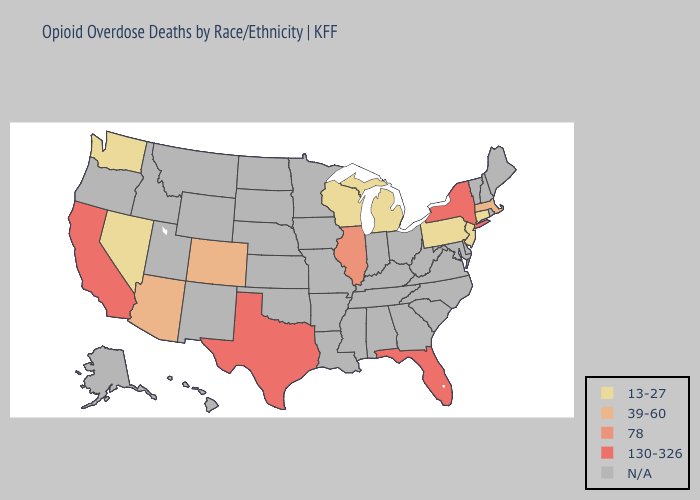What is the lowest value in the Northeast?
Concise answer only. 13-27. What is the lowest value in the South?
Give a very brief answer. 130-326. Which states have the highest value in the USA?
Concise answer only. California, Florida, New York, Texas. Which states have the highest value in the USA?
Short answer required. California, Florida, New York, Texas. Name the states that have a value in the range 130-326?
Write a very short answer. California, Florida, New York, Texas. What is the value of Wyoming?
Keep it brief. N/A. How many symbols are there in the legend?
Be succinct. 5. What is the value of Iowa?
Concise answer only. N/A. Does the first symbol in the legend represent the smallest category?
Quick response, please. Yes. What is the value of North Dakota?
Write a very short answer. N/A. Name the states that have a value in the range 130-326?
Short answer required. California, Florida, New York, Texas. What is the value of Maryland?
Keep it brief. N/A. 